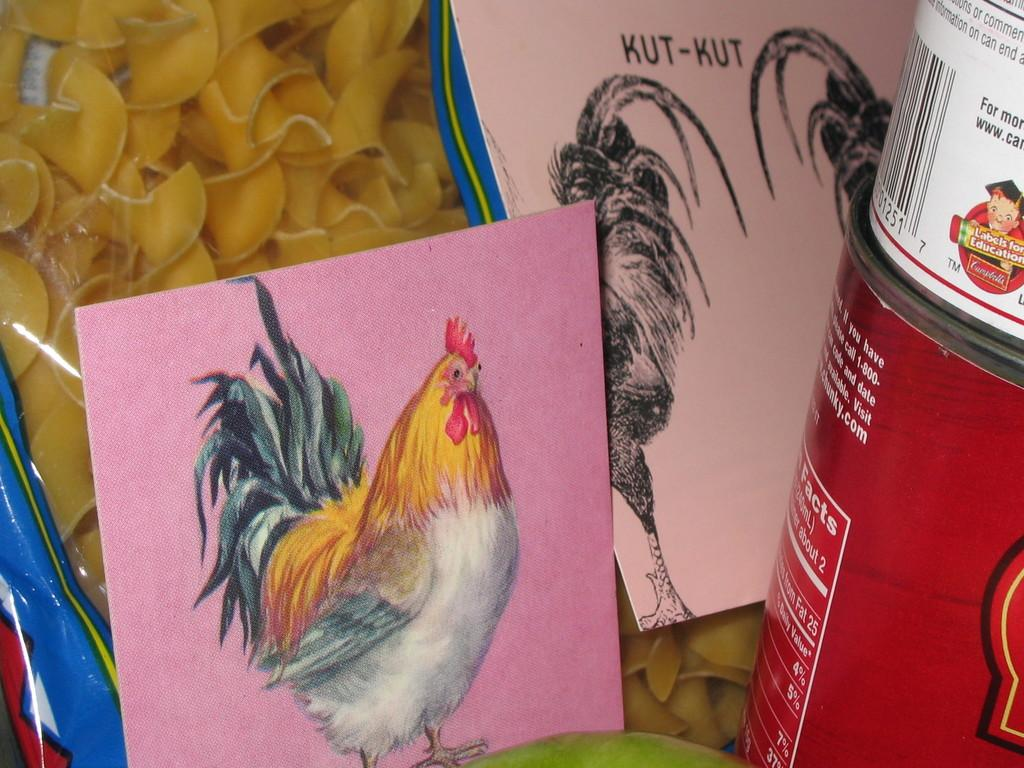What is depicted on the pink card in the image? There is a sketch of a hen on a pink card in the image. Are there any other sketches visible in the image? Yes, there are additional sketches on another board in the image. What type of object can be seen in the image? There is a bottle in the image. What might be the purpose of the food item in the image? The purpose of the food item in the image is not specified, but it could be for consumption or decoration. What type of pen is being used to draw the sketches on the board? There is no pen visible in the image, as the sketches appear to be completed. Can you describe the carriage that is parked next to the board in the image? There is no carriage present in the image; it only features a pink card with a hen sketch, additional sketches on another board, a bottle, and a food item. 